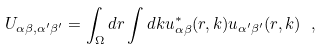Convert formula to latex. <formula><loc_0><loc_0><loc_500><loc_500>U _ { \alpha \beta , \alpha ^ { \prime } \beta ^ { \prime } } = \int _ { \Omega } d { r } \int d { k } u ^ { * } _ { \alpha \beta } ( { r , k } ) u _ { \alpha ^ { \prime } \beta ^ { \prime } } ( { r , k } ) \ ,</formula> 